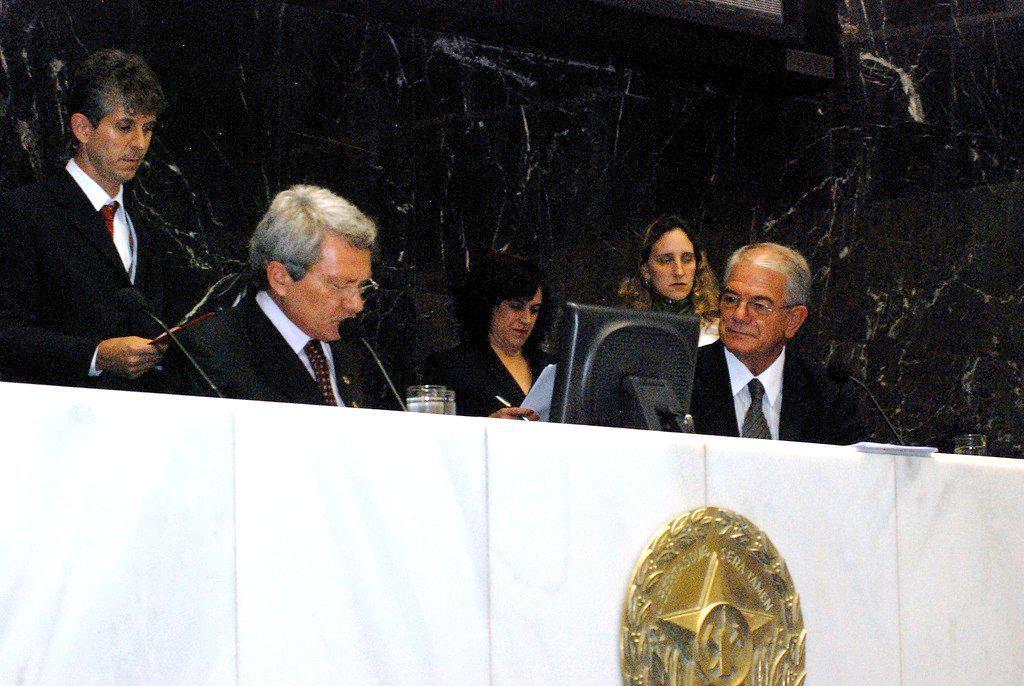How would you summarize this image in a sentence or two? This image consists of five persons wearing black dress. In the front, there is a table in white color. In the background, the walls are in black color. In the middle, the man sitting is talking in a mic. In front of him, there is a monitor. 